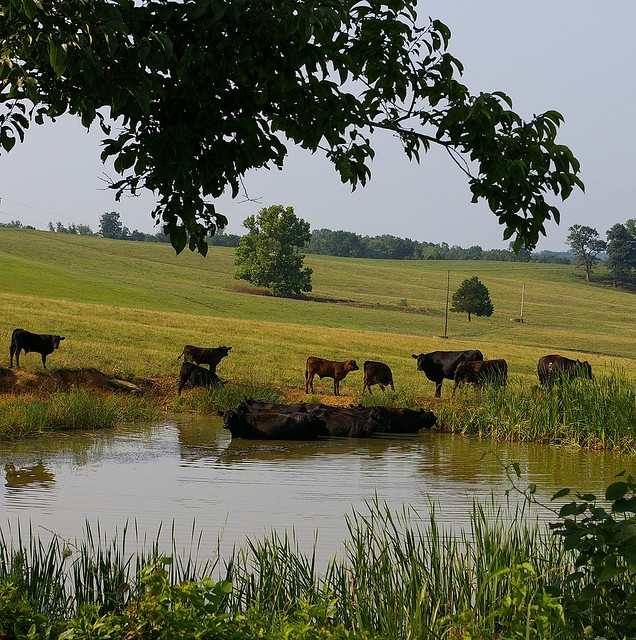Describe the objects in this image and their specific colors. I can see cow in black and olive tones, cow in black, maroon, and olive tones, cow in black and olive tones, cow in black and darkgreen tones, and cow in black, darkgreen, and maroon tones in this image. 